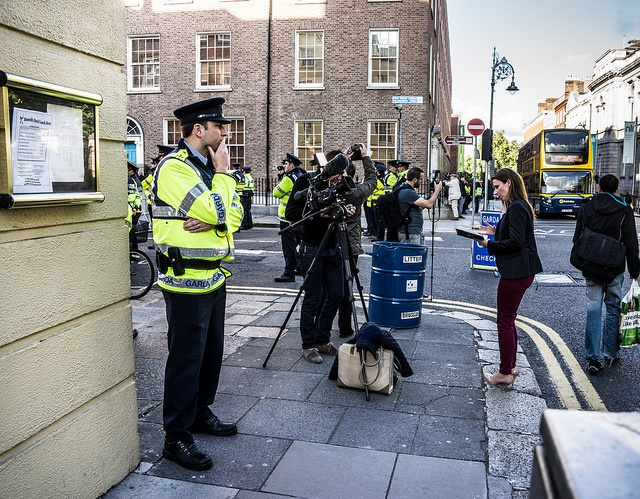Describe the objects in this image and their specific colors. I can see people in darkgray, black, khaki, and gray tones, people in darkgray, black, and gray tones, people in darkgray, black, and gray tones, bus in darkgray, black, gray, and navy tones, and people in darkgray, black, olive, and gray tones in this image. 